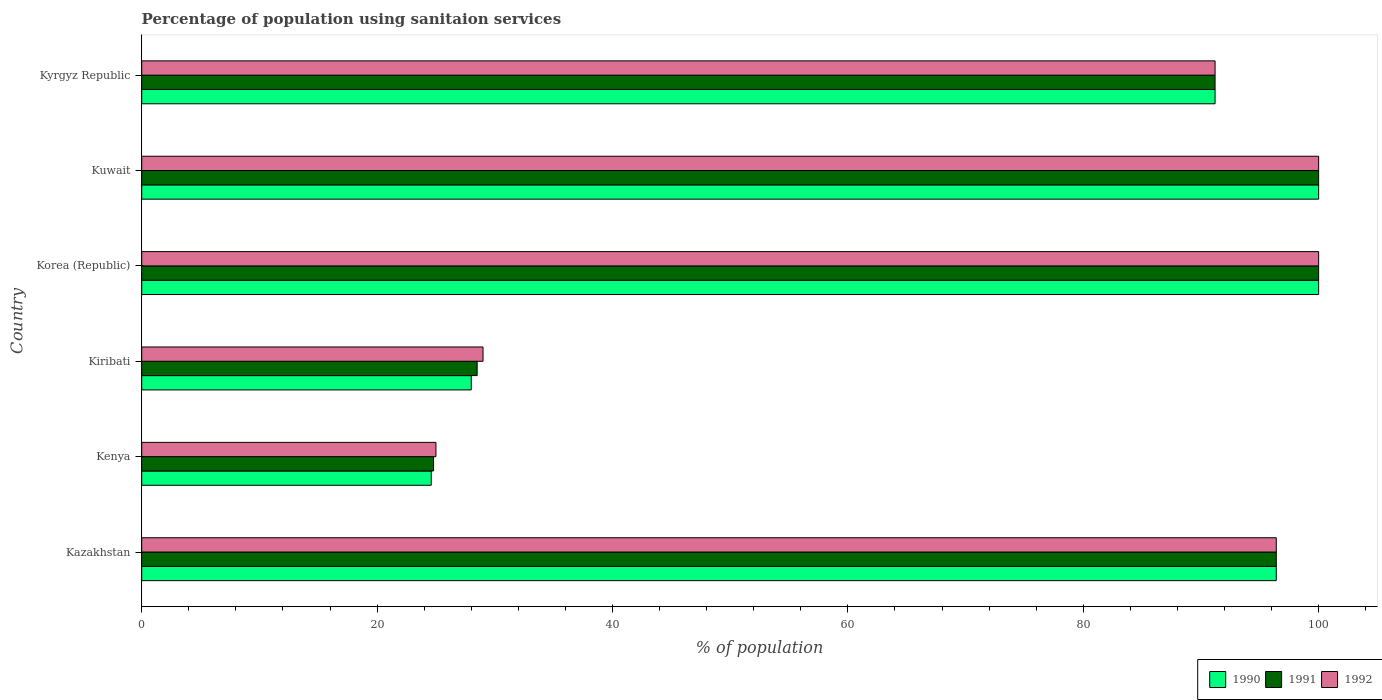How many groups of bars are there?
Offer a terse response. 6. Are the number of bars per tick equal to the number of legend labels?
Your response must be concise. Yes. Are the number of bars on each tick of the Y-axis equal?
Ensure brevity in your answer.  Yes. How many bars are there on the 3rd tick from the top?
Offer a terse response. 3. What is the label of the 2nd group of bars from the top?
Offer a very short reply. Kuwait. In how many cases, is the number of bars for a given country not equal to the number of legend labels?
Your answer should be compact. 0. Across all countries, what is the minimum percentage of population using sanitaion services in 1992?
Your response must be concise. 25. In which country was the percentage of population using sanitaion services in 1991 minimum?
Provide a succinct answer. Kenya. What is the total percentage of population using sanitaion services in 1990 in the graph?
Offer a terse response. 440.2. What is the difference between the percentage of population using sanitaion services in 1990 in Kazakhstan and that in Korea (Republic)?
Offer a very short reply. -3.6. What is the difference between the percentage of population using sanitaion services in 1991 in Kiribati and the percentage of population using sanitaion services in 1992 in Kazakhstan?
Offer a very short reply. -67.9. What is the average percentage of population using sanitaion services in 1992 per country?
Your answer should be compact. 73.6. What is the ratio of the percentage of population using sanitaion services in 1992 in Kiribati to that in Korea (Republic)?
Provide a short and direct response. 0.29. Is the percentage of population using sanitaion services in 1990 in Kazakhstan less than that in Korea (Republic)?
Provide a short and direct response. Yes. What is the difference between the highest and the lowest percentage of population using sanitaion services in 1990?
Your answer should be very brief. 75.4. Is the sum of the percentage of population using sanitaion services in 1991 in Kiribati and Kuwait greater than the maximum percentage of population using sanitaion services in 1990 across all countries?
Make the answer very short. Yes. What does the 2nd bar from the top in Kyrgyz Republic represents?
Your response must be concise. 1991. What does the 2nd bar from the bottom in Kyrgyz Republic represents?
Provide a succinct answer. 1991. Is it the case that in every country, the sum of the percentage of population using sanitaion services in 1990 and percentage of population using sanitaion services in 1991 is greater than the percentage of population using sanitaion services in 1992?
Offer a very short reply. Yes. What is the difference between two consecutive major ticks on the X-axis?
Offer a very short reply. 20. Are the values on the major ticks of X-axis written in scientific E-notation?
Your response must be concise. No. Where does the legend appear in the graph?
Your response must be concise. Bottom right. How many legend labels are there?
Ensure brevity in your answer.  3. What is the title of the graph?
Your response must be concise. Percentage of population using sanitaion services. What is the label or title of the X-axis?
Offer a very short reply. % of population. What is the label or title of the Y-axis?
Offer a terse response. Country. What is the % of population of 1990 in Kazakhstan?
Ensure brevity in your answer.  96.4. What is the % of population of 1991 in Kazakhstan?
Give a very brief answer. 96.4. What is the % of population in 1992 in Kazakhstan?
Ensure brevity in your answer.  96.4. What is the % of population of 1990 in Kenya?
Ensure brevity in your answer.  24.6. What is the % of population of 1991 in Kenya?
Give a very brief answer. 24.8. What is the % of population of 1990 in Kiribati?
Make the answer very short. 28. What is the % of population in 1990 in Korea (Republic)?
Make the answer very short. 100. What is the % of population of 1991 in Korea (Republic)?
Make the answer very short. 100. What is the % of population in 1992 in Korea (Republic)?
Ensure brevity in your answer.  100. What is the % of population in 1991 in Kuwait?
Provide a short and direct response. 100. What is the % of population of 1990 in Kyrgyz Republic?
Keep it short and to the point. 91.2. What is the % of population in 1991 in Kyrgyz Republic?
Ensure brevity in your answer.  91.2. What is the % of population of 1992 in Kyrgyz Republic?
Ensure brevity in your answer.  91.2. Across all countries, what is the minimum % of population in 1990?
Provide a short and direct response. 24.6. Across all countries, what is the minimum % of population of 1991?
Your response must be concise. 24.8. What is the total % of population in 1990 in the graph?
Ensure brevity in your answer.  440.2. What is the total % of population of 1991 in the graph?
Offer a terse response. 440.9. What is the total % of population of 1992 in the graph?
Your answer should be compact. 441.6. What is the difference between the % of population in 1990 in Kazakhstan and that in Kenya?
Keep it short and to the point. 71.8. What is the difference between the % of population in 1991 in Kazakhstan and that in Kenya?
Your answer should be compact. 71.6. What is the difference between the % of population of 1992 in Kazakhstan and that in Kenya?
Offer a very short reply. 71.4. What is the difference between the % of population of 1990 in Kazakhstan and that in Kiribati?
Your response must be concise. 68.4. What is the difference between the % of population in 1991 in Kazakhstan and that in Kiribati?
Give a very brief answer. 67.9. What is the difference between the % of population of 1992 in Kazakhstan and that in Kiribati?
Your response must be concise. 67.4. What is the difference between the % of population in 1990 in Kazakhstan and that in Korea (Republic)?
Your answer should be compact. -3.6. What is the difference between the % of population in 1992 in Kazakhstan and that in Korea (Republic)?
Your answer should be compact. -3.6. What is the difference between the % of population of 1990 in Kazakhstan and that in Kuwait?
Keep it short and to the point. -3.6. What is the difference between the % of population in 1992 in Kazakhstan and that in Kyrgyz Republic?
Provide a succinct answer. 5.2. What is the difference between the % of population in 1990 in Kenya and that in Kiribati?
Ensure brevity in your answer.  -3.4. What is the difference between the % of population in 1991 in Kenya and that in Kiribati?
Your answer should be compact. -3.7. What is the difference between the % of population in 1992 in Kenya and that in Kiribati?
Give a very brief answer. -4. What is the difference between the % of population of 1990 in Kenya and that in Korea (Republic)?
Keep it short and to the point. -75.4. What is the difference between the % of population in 1991 in Kenya and that in Korea (Republic)?
Offer a very short reply. -75.2. What is the difference between the % of population of 1992 in Kenya and that in Korea (Republic)?
Ensure brevity in your answer.  -75. What is the difference between the % of population of 1990 in Kenya and that in Kuwait?
Make the answer very short. -75.4. What is the difference between the % of population in 1991 in Kenya and that in Kuwait?
Your response must be concise. -75.2. What is the difference between the % of population in 1992 in Kenya and that in Kuwait?
Offer a very short reply. -75. What is the difference between the % of population of 1990 in Kenya and that in Kyrgyz Republic?
Provide a succinct answer. -66.6. What is the difference between the % of population in 1991 in Kenya and that in Kyrgyz Republic?
Your answer should be compact. -66.4. What is the difference between the % of population of 1992 in Kenya and that in Kyrgyz Republic?
Offer a very short reply. -66.2. What is the difference between the % of population in 1990 in Kiribati and that in Korea (Republic)?
Give a very brief answer. -72. What is the difference between the % of population in 1991 in Kiribati and that in Korea (Republic)?
Give a very brief answer. -71.5. What is the difference between the % of population in 1992 in Kiribati and that in Korea (Republic)?
Provide a short and direct response. -71. What is the difference between the % of population of 1990 in Kiribati and that in Kuwait?
Provide a succinct answer. -72. What is the difference between the % of population of 1991 in Kiribati and that in Kuwait?
Provide a succinct answer. -71.5. What is the difference between the % of population in 1992 in Kiribati and that in Kuwait?
Offer a very short reply. -71. What is the difference between the % of population in 1990 in Kiribati and that in Kyrgyz Republic?
Give a very brief answer. -63.2. What is the difference between the % of population in 1991 in Kiribati and that in Kyrgyz Republic?
Keep it short and to the point. -62.7. What is the difference between the % of population in 1992 in Kiribati and that in Kyrgyz Republic?
Make the answer very short. -62.2. What is the difference between the % of population in 1990 in Korea (Republic) and that in Kuwait?
Keep it short and to the point. 0. What is the difference between the % of population of 1991 in Korea (Republic) and that in Kyrgyz Republic?
Your response must be concise. 8.8. What is the difference between the % of population in 1991 in Kuwait and that in Kyrgyz Republic?
Keep it short and to the point. 8.8. What is the difference between the % of population of 1990 in Kazakhstan and the % of population of 1991 in Kenya?
Offer a very short reply. 71.6. What is the difference between the % of population of 1990 in Kazakhstan and the % of population of 1992 in Kenya?
Give a very brief answer. 71.4. What is the difference between the % of population in 1991 in Kazakhstan and the % of population in 1992 in Kenya?
Ensure brevity in your answer.  71.4. What is the difference between the % of population of 1990 in Kazakhstan and the % of population of 1991 in Kiribati?
Provide a succinct answer. 67.9. What is the difference between the % of population of 1990 in Kazakhstan and the % of population of 1992 in Kiribati?
Offer a very short reply. 67.4. What is the difference between the % of population in 1991 in Kazakhstan and the % of population in 1992 in Kiribati?
Your answer should be compact. 67.4. What is the difference between the % of population in 1990 in Kazakhstan and the % of population in 1992 in Korea (Republic)?
Ensure brevity in your answer.  -3.6. What is the difference between the % of population in 1990 in Kazakhstan and the % of population in 1992 in Kuwait?
Provide a short and direct response. -3.6. What is the difference between the % of population of 1991 in Kazakhstan and the % of population of 1992 in Kuwait?
Offer a terse response. -3.6. What is the difference between the % of population in 1990 in Kazakhstan and the % of population in 1991 in Kyrgyz Republic?
Make the answer very short. 5.2. What is the difference between the % of population in 1990 in Kazakhstan and the % of population in 1992 in Kyrgyz Republic?
Make the answer very short. 5.2. What is the difference between the % of population in 1991 in Kazakhstan and the % of population in 1992 in Kyrgyz Republic?
Your answer should be compact. 5.2. What is the difference between the % of population in 1990 in Kenya and the % of population in 1991 in Kiribati?
Keep it short and to the point. -3.9. What is the difference between the % of population of 1990 in Kenya and the % of population of 1991 in Korea (Republic)?
Offer a terse response. -75.4. What is the difference between the % of population in 1990 in Kenya and the % of population in 1992 in Korea (Republic)?
Your answer should be compact. -75.4. What is the difference between the % of population in 1991 in Kenya and the % of population in 1992 in Korea (Republic)?
Provide a succinct answer. -75.2. What is the difference between the % of population of 1990 in Kenya and the % of population of 1991 in Kuwait?
Keep it short and to the point. -75.4. What is the difference between the % of population of 1990 in Kenya and the % of population of 1992 in Kuwait?
Your response must be concise. -75.4. What is the difference between the % of population in 1991 in Kenya and the % of population in 1992 in Kuwait?
Offer a terse response. -75.2. What is the difference between the % of population of 1990 in Kenya and the % of population of 1991 in Kyrgyz Republic?
Offer a terse response. -66.6. What is the difference between the % of population of 1990 in Kenya and the % of population of 1992 in Kyrgyz Republic?
Offer a very short reply. -66.6. What is the difference between the % of population of 1991 in Kenya and the % of population of 1992 in Kyrgyz Republic?
Your answer should be very brief. -66.4. What is the difference between the % of population of 1990 in Kiribati and the % of population of 1991 in Korea (Republic)?
Make the answer very short. -72. What is the difference between the % of population in 1990 in Kiribati and the % of population in 1992 in Korea (Republic)?
Your answer should be very brief. -72. What is the difference between the % of population of 1991 in Kiribati and the % of population of 1992 in Korea (Republic)?
Your answer should be compact. -71.5. What is the difference between the % of population in 1990 in Kiribati and the % of population in 1991 in Kuwait?
Provide a succinct answer. -72. What is the difference between the % of population in 1990 in Kiribati and the % of population in 1992 in Kuwait?
Provide a succinct answer. -72. What is the difference between the % of population in 1991 in Kiribati and the % of population in 1992 in Kuwait?
Make the answer very short. -71.5. What is the difference between the % of population in 1990 in Kiribati and the % of population in 1991 in Kyrgyz Republic?
Your answer should be compact. -63.2. What is the difference between the % of population of 1990 in Kiribati and the % of population of 1992 in Kyrgyz Republic?
Ensure brevity in your answer.  -63.2. What is the difference between the % of population of 1991 in Kiribati and the % of population of 1992 in Kyrgyz Republic?
Give a very brief answer. -62.7. What is the difference between the % of population in 1991 in Korea (Republic) and the % of population in 1992 in Kuwait?
Make the answer very short. 0. What is the difference between the % of population of 1990 in Korea (Republic) and the % of population of 1991 in Kyrgyz Republic?
Offer a very short reply. 8.8. What is the difference between the % of population of 1990 in Korea (Republic) and the % of population of 1992 in Kyrgyz Republic?
Keep it short and to the point. 8.8. What is the difference between the % of population of 1991 in Korea (Republic) and the % of population of 1992 in Kyrgyz Republic?
Offer a very short reply. 8.8. What is the difference between the % of population of 1991 in Kuwait and the % of population of 1992 in Kyrgyz Republic?
Ensure brevity in your answer.  8.8. What is the average % of population in 1990 per country?
Make the answer very short. 73.37. What is the average % of population of 1991 per country?
Offer a very short reply. 73.48. What is the average % of population of 1992 per country?
Give a very brief answer. 73.6. What is the difference between the % of population in 1990 and % of population in 1991 in Kazakhstan?
Your answer should be very brief. 0. What is the difference between the % of population of 1990 and % of population of 1992 in Kazakhstan?
Give a very brief answer. 0. What is the difference between the % of population in 1991 and % of population in 1992 in Kazakhstan?
Provide a short and direct response. 0. What is the difference between the % of population of 1990 and % of population of 1991 in Kenya?
Offer a terse response. -0.2. What is the difference between the % of population of 1990 and % of population of 1991 in Kiribati?
Your answer should be compact. -0.5. What is the difference between the % of population of 1990 and % of population of 1992 in Kiribati?
Your answer should be very brief. -1. What is the difference between the % of population of 1991 and % of population of 1992 in Kiribati?
Give a very brief answer. -0.5. What is the difference between the % of population in 1990 and % of population in 1991 in Korea (Republic)?
Provide a succinct answer. 0. What is the difference between the % of population in 1990 and % of population in 1992 in Kuwait?
Offer a very short reply. 0. What is the difference between the % of population in 1991 and % of population in 1992 in Kyrgyz Republic?
Your answer should be very brief. 0. What is the ratio of the % of population of 1990 in Kazakhstan to that in Kenya?
Your answer should be compact. 3.92. What is the ratio of the % of population in 1991 in Kazakhstan to that in Kenya?
Your answer should be compact. 3.89. What is the ratio of the % of population in 1992 in Kazakhstan to that in Kenya?
Offer a very short reply. 3.86. What is the ratio of the % of population of 1990 in Kazakhstan to that in Kiribati?
Provide a succinct answer. 3.44. What is the ratio of the % of population of 1991 in Kazakhstan to that in Kiribati?
Give a very brief answer. 3.38. What is the ratio of the % of population of 1992 in Kazakhstan to that in Kiribati?
Your answer should be very brief. 3.32. What is the ratio of the % of population of 1992 in Kazakhstan to that in Korea (Republic)?
Offer a terse response. 0.96. What is the ratio of the % of population in 1990 in Kazakhstan to that in Kuwait?
Your answer should be very brief. 0.96. What is the ratio of the % of population in 1990 in Kazakhstan to that in Kyrgyz Republic?
Offer a very short reply. 1.06. What is the ratio of the % of population of 1991 in Kazakhstan to that in Kyrgyz Republic?
Give a very brief answer. 1.06. What is the ratio of the % of population in 1992 in Kazakhstan to that in Kyrgyz Republic?
Your answer should be compact. 1.06. What is the ratio of the % of population in 1990 in Kenya to that in Kiribati?
Your answer should be compact. 0.88. What is the ratio of the % of population in 1991 in Kenya to that in Kiribati?
Provide a succinct answer. 0.87. What is the ratio of the % of population in 1992 in Kenya to that in Kiribati?
Give a very brief answer. 0.86. What is the ratio of the % of population in 1990 in Kenya to that in Korea (Republic)?
Provide a short and direct response. 0.25. What is the ratio of the % of population in 1991 in Kenya to that in Korea (Republic)?
Ensure brevity in your answer.  0.25. What is the ratio of the % of population in 1990 in Kenya to that in Kuwait?
Give a very brief answer. 0.25. What is the ratio of the % of population in 1991 in Kenya to that in Kuwait?
Your answer should be very brief. 0.25. What is the ratio of the % of population of 1990 in Kenya to that in Kyrgyz Republic?
Offer a very short reply. 0.27. What is the ratio of the % of population in 1991 in Kenya to that in Kyrgyz Republic?
Keep it short and to the point. 0.27. What is the ratio of the % of population in 1992 in Kenya to that in Kyrgyz Republic?
Your response must be concise. 0.27. What is the ratio of the % of population of 1990 in Kiribati to that in Korea (Republic)?
Your answer should be compact. 0.28. What is the ratio of the % of population in 1991 in Kiribati to that in Korea (Republic)?
Offer a very short reply. 0.28. What is the ratio of the % of population in 1992 in Kiribati to that in Korea (Republic)?
Make the answer very short. 0.29. What is the ratio of the % of population in 1990 in Kiribati to that in Kuwait?
Offer a terse response. 0.28. What is the ratio of the % of population of 1991 in Kiribati to that in Kuwait?
Ensure brevity in your answer.  0.28. What is the ratio of the % of population of 1992 in Kiribati to that in Kuwait?
Ensure brevity in your answer.  0.29. What is the ratio of the % of population in 1990 in Kiribati to that in Kyrgyz Republic?
Make the answer very short. 0.31. What is the ratio of the % of population in 1991 in Kiribati to that in Kyrgyz Republic?
Keep it short and to the point. 0.31. What is the ratio of the % of population in 1992 in Kiribati to that in Kyrgyz Republic?
Your answer should be very brief. 0.32. What is the ratio of the % of population in 1990 in Korea (Republic) to that in Kyrgyz Republic?
Ensure brevity in your answer.  1.1. What is the ratio of the % of population in 1991 in Korea (Republic) to that in Kyrgyz Republic?
Your answer should be compact. 1.1. What is the ratio of the % of population in 1992 in Korea (Republic) to that in Kyrgyz Republic?
Provide a succinct answer. 1.1. What is the ratio of the % of population in 1990 in Kuwait to that in Kyrgyz Republic?
Offer a terse response. 1.1. What is the ratio of the % of population of 1991 in Kuwait to that in Kyrgyz Republic?
Keep it short and to the point. 1.1. What is the ratio of the % of population in 1992 in Kuwait to that in Kyrgyz Republic?
Your answer should be very brief. 1.1. What is the difference between the highest and the second highest % of population in 1990?
Offer a very short reply. 0. What is the difference between the highest and the second highest % of population of 1992?
Make the answer very short. 0. What is the difference between the highest and the lowest % of population in 1990?
Provide a short and direct response. 75.4. What is the difference between the highest and the lowest % of population in 1991?
Make the answer very short. 75.2. 